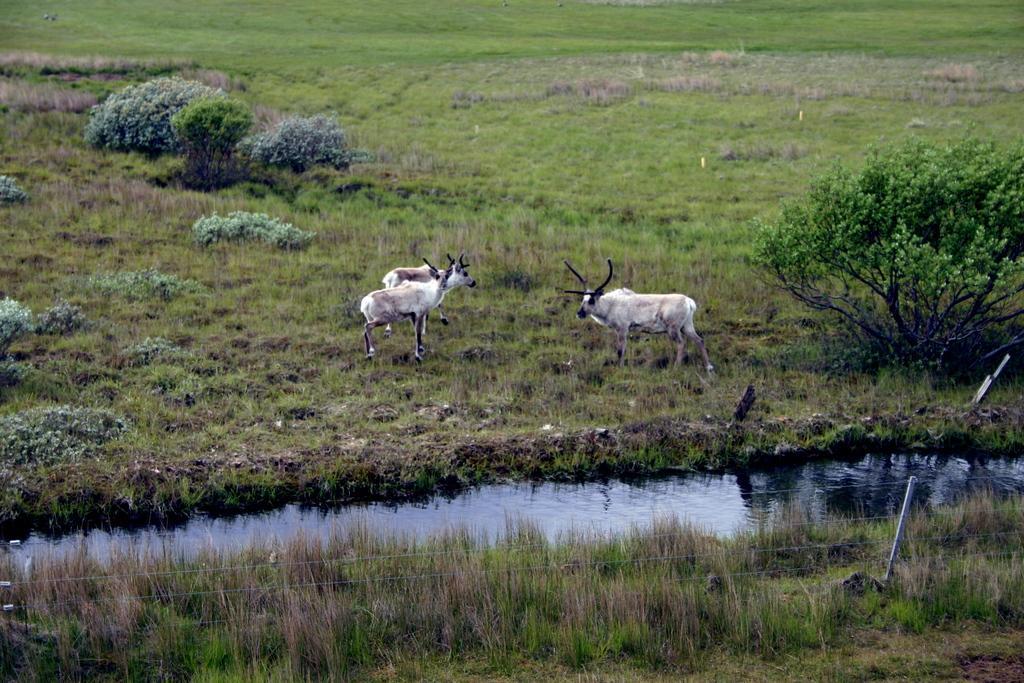How would you summarize this image in a sentence or two? At the bottom of this image, there is a fence and there is a grass on the ground. Beside this ground, there is a lake. Outside this lake, there are three animals on the ground, on which there are trees and grass on the ground. 